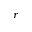<formula> <loc_0><loc_0><loc_500><loc_500>r</formula> 